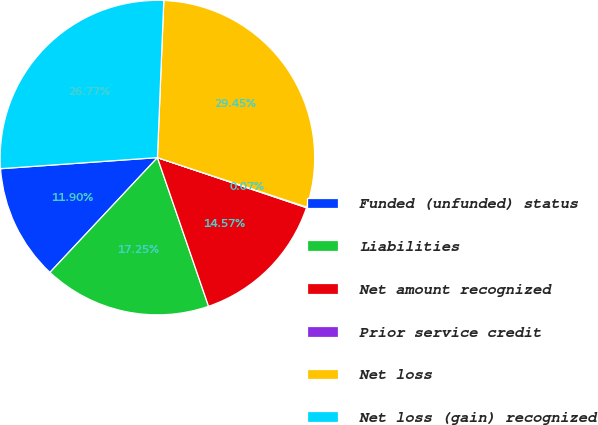Convert chart. <chart><loc_0><loc_0><loc_500><loc_500><pie_chart><fcel>Funded (unfunded) status<fcel>Liabilities<fcel>Net amount recognized<fcel>Prior service credit<fcel>Net loss<fcel>Net loss (gain) recognized<nl><fcel>11.9%<fcel>17.25%<fcel>14.57%<fcel>0.07%<fcel>29.45%<fcel>26.77%<nl></chart> 